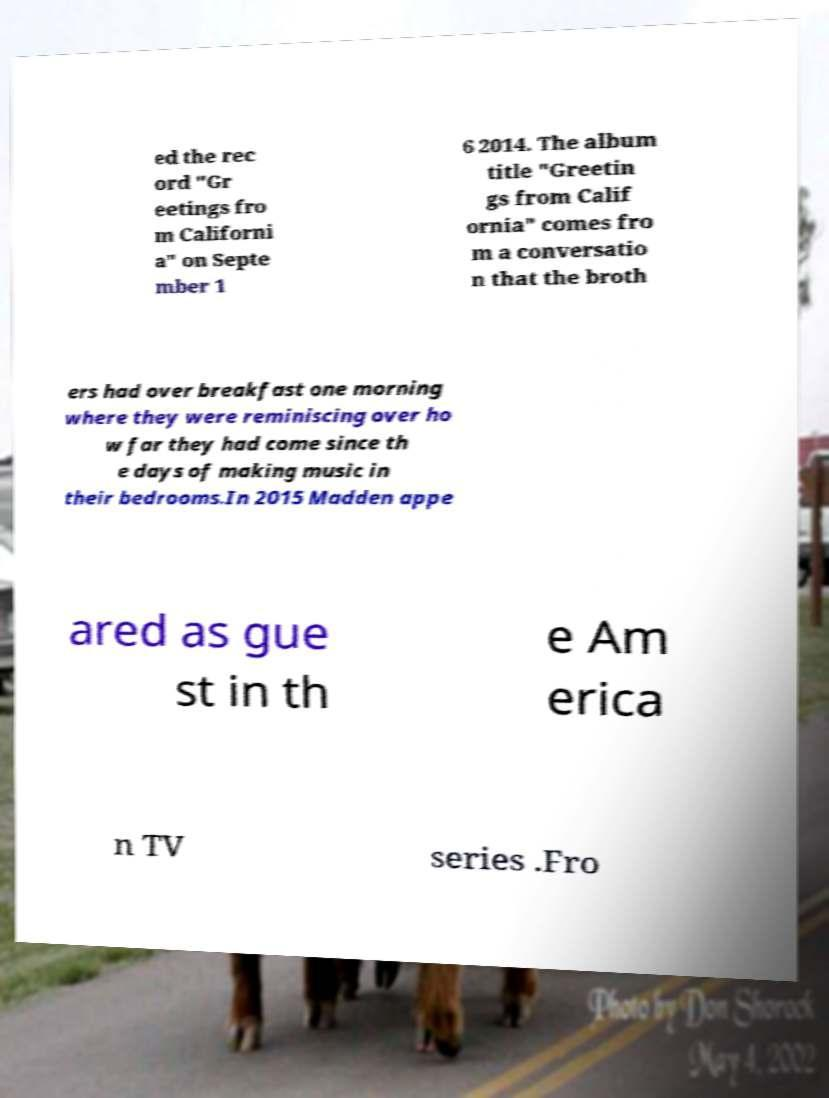Could you assist in decoding the text presented in this image and type it out clearly? ed the rec ord "Gr eetings fro m Californi a" on Septe mber 1 6 2014. The album title "Greetin gs from Calif ornia" comes fro m a conversatio n that the broth ers had over breakfast one morning where they were reminiscing over ho w far they had come since th e days of making music in their bedrooms.In 2015 Madden appe ared as gue st in th e Am erica n TV series .Fro 